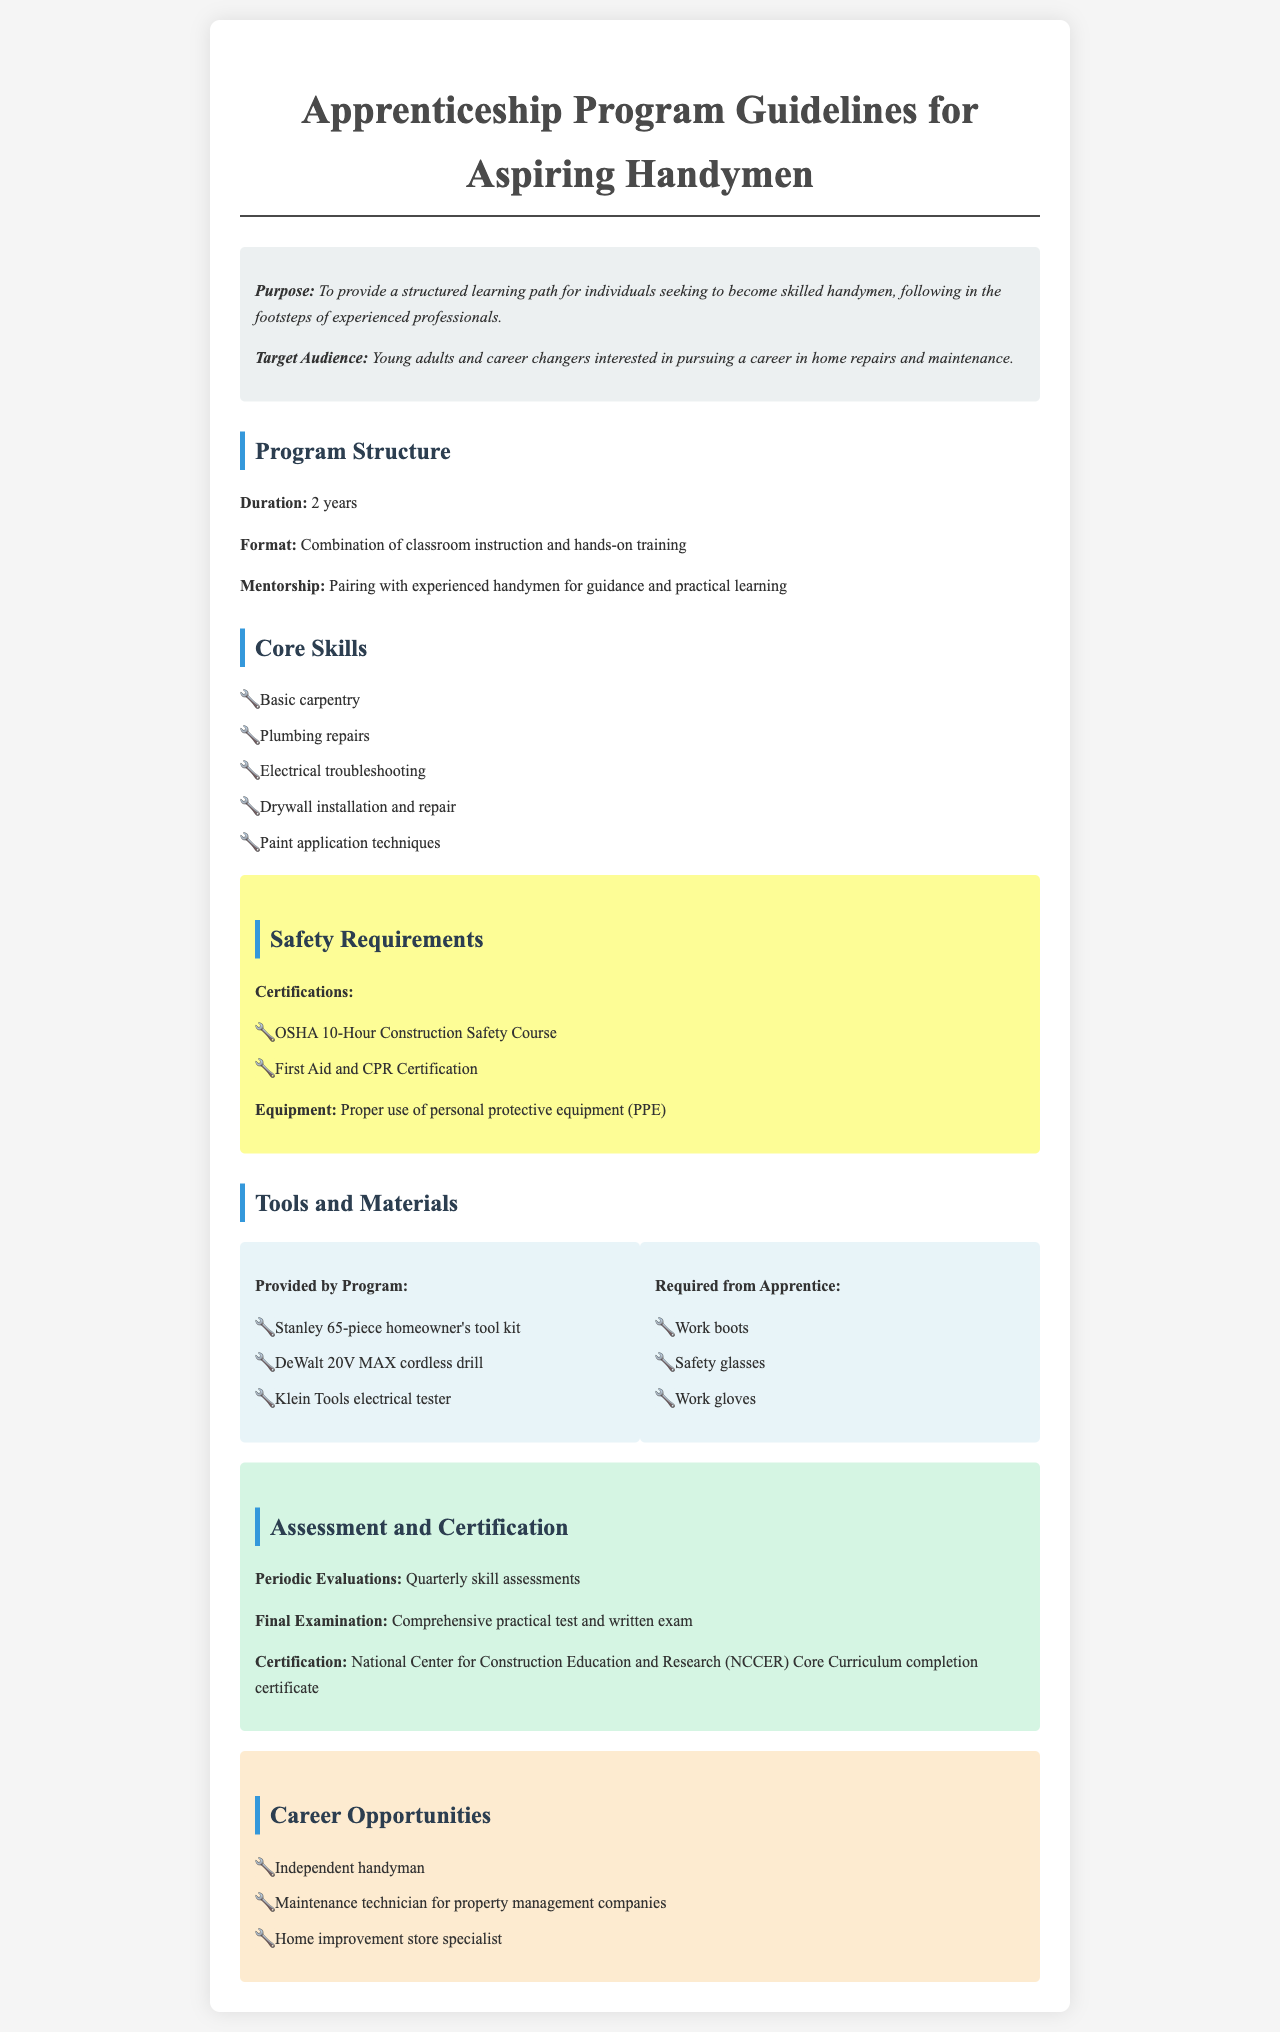what is the duration of the program? The document states the program duration is listed under "Program Structure" as 2 years.
Answer: 2 years who is the target audience for the apprenticeship program? The document mentions in the "Purpose" section that the target audience includes young adults and career changers interested in pursuing a career in home repairs and maintenance.
Answer: Young adults and career changers what certification is required for safety? The "Safety Requirements" section lists OSHA 10-Hour Construction Safety Course as one of the required certifications.
Answer: OSHA 10-Hour Construction Safety Course how often are skill assessments conducted? The "Assessment and Certification" section specifies that periodic evaluations occur quarterly.
Answer: Quarterly what types of tools are provided by the program? The "Tools and Materials" section lists a Stanley 65-piece homeowner's tool kit, DeWalt 20V MAX cordless drill, and Klein Tools electrical tester as tools provided by the program.
Answer: Stanley 65-piece homeowner's tool kit, DeWalt 20V MAX cordless drill, Klein Tools electrical tester what is the final examination composed of? The "Assessment and Certification" section states that the final examination includes a comprehensive practical test and a written exam.
Answer: Comprehensive practical test and written exam list one career opportunity mentioned in the document. The "Career Opportunities" section provides various possibilities, one of which is independent handyman.
Answer: Independent handyman what is the purpose of the apprenticeship program? The introductory section of the document defines the purpose as providing a structured learning path for individuals seeking to become skilled handymen.
Answer: To provide a structured learning path what personal protective equipment must be used? The "Safety Requirements" section mentions the proper use of personal protective equipment (PPE) as a requirement.
Answer: Personal protective equipment (PPE) 